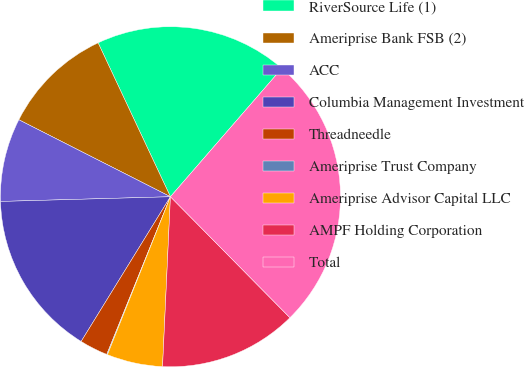Convert chart. <chart><loc_0><loc_0><loc_500><loc_500><pie_chart><fcel>RiverSource Life (1)<fcel>Ameriprise Bank FSB (2)<fcel>ACC<fcel>Columbia Management Investment<fcel>Threadneedle<fcel>Ameriprise Trust Company<fcel>Ameriprise Advisor Capital LLC<fcel>AMPF Holding Corporation<fcel>Total<nl><fcel>18.37%<fcel>10.53%<fcel>7.92%<fcel>15.76%<fcel>2.69%<fcel>0.07%<fcel>5.3%<fcel>13.14%<fcel>26.22%<nl></chart> 